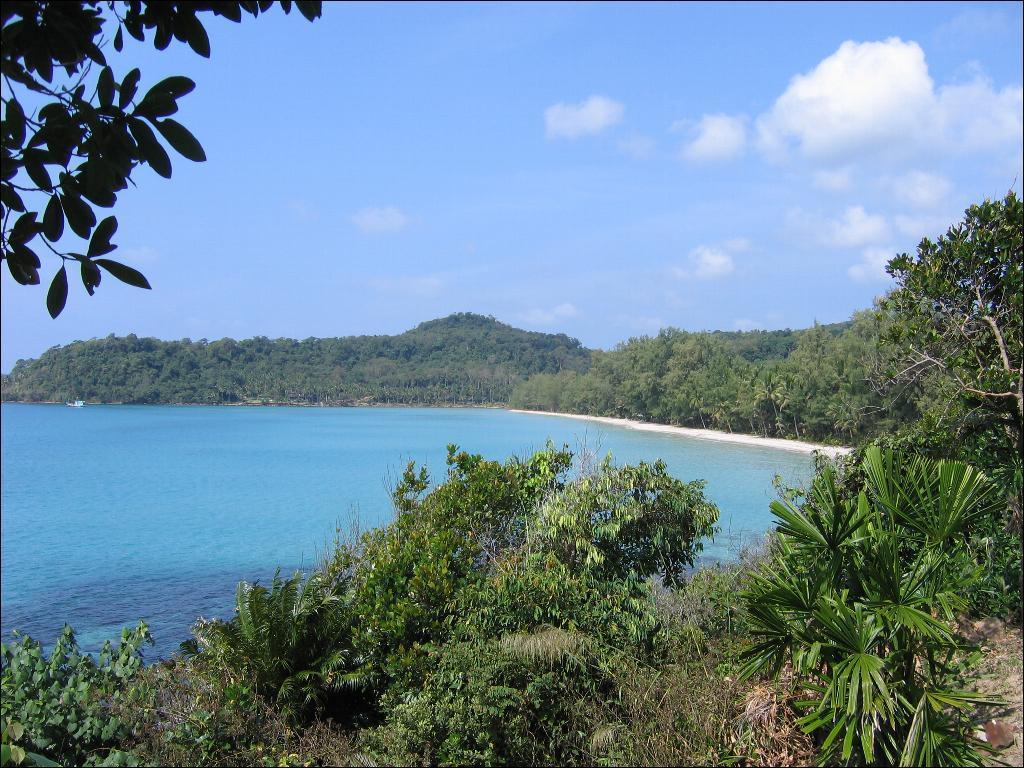Where was the picture taken? The picture was clicked outside the city. What can be seen in the foreground of the image? There are plants in the foreground of the image. What is the main feature in the center of the image? There is a water body in the center of the image. What is visible in the background of the image? There are trees and the sky in the background of the image. What grade did the queen give to the water body in the image? There is no queen present in the image, and therefore no grade can be given. 